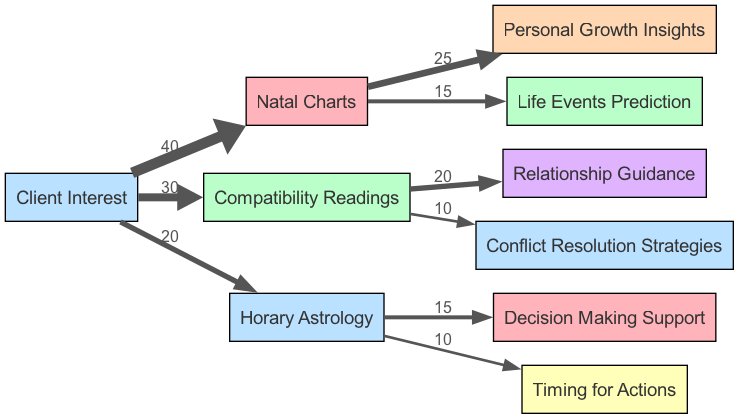What is the total client interest for astrological practices shown in the diagram? To find the total client interest, sum the values of all three practices listed: Natal Charts (40), Compatibility Readings (30), and Horary Astrology (20). Thus, total interest = 40 + 30 + 20 = 90.
Answer: 90 Which astrological practice area has the least client interest? Comparing the values, Natal Charts has 40, Compatibility Readings has 30, and Horary Astrology has 20. The area with the least interest is Horary Astrology with a value of 20.
Answer: Horary Astrology What percentage of client interest does Compatibility Readings represent? First, determine the value of Compatibility Readings which is 30. Next, divide this by the total client interest (90) and multiply by 100 to find the percentage: (30 / 90) * 100 = 33.33%.
Answer: 33.33% What is the relationship between Natal Charts and Personal Growth Insights? The diagram shows a direct edge from Natal Charts to Personal Growth Insights with a value of 25. This indicates that out of the client interest in Natal Charts, 25 units lead to Personal Growth Insights.
Answer: 25 What is the combined value of insights derived from Compatibility Readings? There are two flows from Compatibility Readings: Relationship Guidance (20) and Conflict Resolution Strategies (10). Adding these together gives 20 + 10 = 30.
Answer: 30 How many different practice areas are represented in this diagram? There are three practice areas in the diagram: Natal Charts, Compatibility Readings, and Horary Astrology. Thus, the total number of areas is 3.
Answer: 3 Which astrological practice area provides the highest support for decision-making? Checking the flows for decision-making support, Horary Astrology provides 15 for Decision Making Support. This is the only practice area mentioned for this type of support in the diagram, so it holds this value.
Answer: 15 Based on the diagram, what is the flow from Horary Astrology to Timing for Actions? The diagram indicates that Horary Astrology has a flow to Timing for Actions with a value of 10. This signifies that out of the interest in Horary Astrology, 10 units contribute towards Timing for Actions.
Answer: 10 